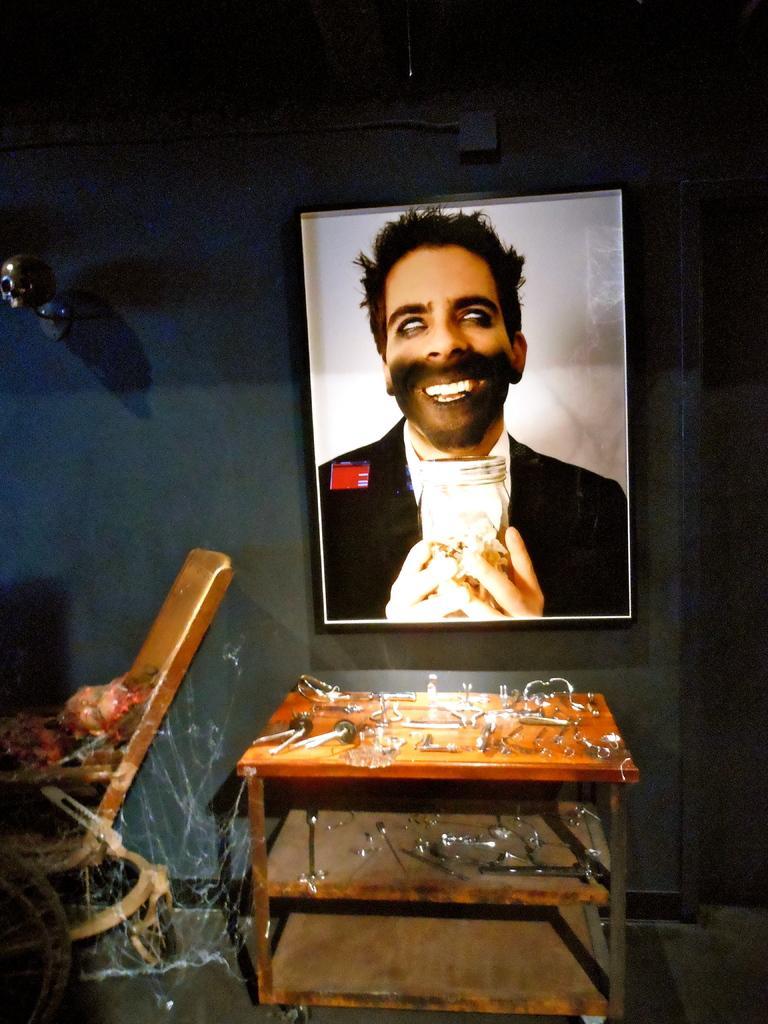How would you summarize this image in a sentence or two? In this picture we can see a frame on the wall. There are few objects on the table. We can see a skull on the wall. There is a chair on the left side. 